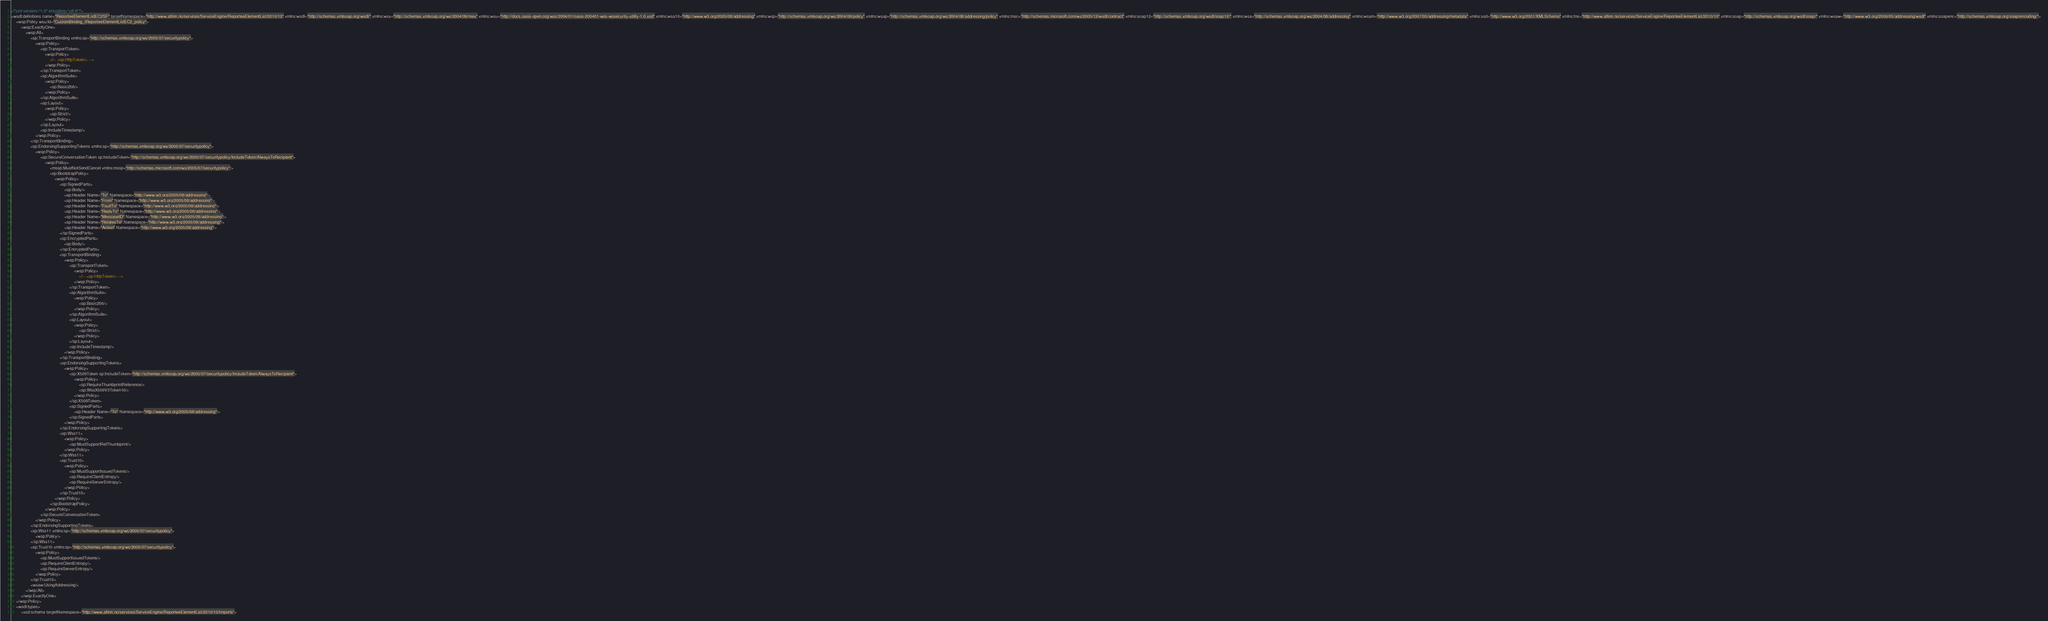<code> <loc_0><loc_0><loc_500><loc_500><_XML_><?xml version="1.0" encoding="utf-8"?>
<wsdl:definitions name="ReporteeElementListEC2SF" targetNamespace="http://www.altinn.no/services/ServiceEngine/ReporteeElementList/2010/10" xmlns:wsdl="http://schemas.xmlsoap.org/wsdl/" xmlns:wsx="http://schemas.xmlsoap.org/ws/2004/09/mex" xmlns:wsu="http://docs.oasis-open.org/wss/2004/01/oasis-200401-wss-wssecurity-utility-1.0.xsd" xmlns:wsa10="http://www.w3.org/2005/08/addressing" xmlns:wsp="http://schemas.xmlsoap.org/ws/2004/09/policy" xmlns:wsap="http://schemas.xmlsoap.org/ws/2004/08/addressing/policy" xmlns:msc="http://schemas.microsoft.com/ws/2005/12/wsdl/contract" xmlns:soap12="http://schemas.xmlsoap.org/wsdl/soap12/" xmlns:wsa="http://schemas.xmlsoap.org/ws/2004/08/addressing" xmlns:wsam="http://www.w3.org/2007/05/addressing/metadata" xmlns:xsd="http://www.w3.org/2001/XMLSchema" xmlns:tns="http://www.altinn.no/services/ServiceEngine/ReporteeElementList/2010/10" xmlns:soap="http://schemas.xmlsoap.org/wsdl/soap/" xmlns:wsaw="http://www.w3.org/2006/05/addressing/wsdl" xmlns:soapenc="http://schemas.xmlsoap.org/soap/encoding/">
    <wsp:Policy wsu:Id="CustomBinding_IReporteeElementListEC2_policy">
        <wsp:ExactlyOne>
            <wsp:All>
                <sp:TransportBinding xmlns:sp="http://schemas.xmlsoap.org/ws/2005/07/securitypolicy">
                    <wsp:Policy>
                        <sp:TransportToken>
                            <wsp:Policy>
                                <!-- <sp:HttpToken/> -->
                            </wsp:Policy>
                        </sp:TransportToken>
                        <sp:AlgorithmSuite>
                            <wsp:Policy>
                                <sp:Basic256/>
                            </wsp:Policy>
                        </sp:AlgorithmSuite>
                        <sp:Layout>
                            <wsp:Policy>
                                <sp:Strict/>
                            </wsp:Policy>
                        </sp:Layout>
                        <sp:IncludeTimestamp/>
                    </wsp:Policy>
                </sp:TransportBinding>
                <sp:EndorsingSupportingTokens xmlns:sp="http://schemas.xmlsoap.org/ws/2005/07/securitypolicy">
                    <wsp:Policy>
                        <sp:SecureConversationToken sp:IncludeToken="http://schemas.xmlsoap.org/ws/2005/07/securitypolicy/IncludeToken/AlwaysToRecipient">
                            <wsp:Policy>
                                <mssp:MustNotSendCancel xmlns:mssp="http://schemas.microsoft.com/ws/2005/07/securitypolicy"/>
                                <sp:BootstrapPolicy>
                                    <wsp:Policy>
                                        <sp:SignedParts>
                                            <sp:Body/>
                                            <sp:Header Name="To" Namespace="http://www.w3.org/2005/08/addressing"/>
                                            <sp:Header Name="From" Namespace="http://www.w3.org/2005/08/addressing"/>
                                            <sp:Header Name="FaultTo" Namespace="http://www.w3.org/2005/08/addressing"/>
                                            <sp:Header Name="ReplyTo" Namespace="http://www.w3.org/2005/08/addressing"/>
                                            <sp:Header Name="MessageID" Namespace="http://www.w3.org/2005/08/addressing"/>
                                            <sp:Header Name="RelatesTo" Namespace="http://www.w3.org/2005/08/addressing"/>
                                            <sp:Header Name="Action" Namespace="http://www.w3.org/2005/08/addressing"/>
                                        </sp:SignedParts>
                                        <sp:EncryptedParts>
                                            <sp:Body/>
                                        </sp:EncryptedParts>
                                        <sp:TransportBinding>
                                            <wsp:Policy>
                                                <sp:TransportToken>
                                                    <wsp:Policy>
                                                        <!-- <sp:HttpToken/> -->
                                                    </wsp:Policy>
                                                </sp:TransportToken>
                                                <sp:AlgorithmSuite>
                                                    <wsp:Policy>
                                                        <sp:Basic256/>
                                                    </wsp:Policy>
                                                </sp:AlgorithmSuite>
                                                <sp:Layout>
                                                    <wsp:Policy>
                                                        <sp:Strict/>
                                                    </wsp:Policy>
                                                </sp:Layout>
                                                <sp:IncludeTimestamp/>
                                            </wsp:Policy>
                                        </sp:TransportBinding>
                                        <sp:EndorsingSupportingTokens>
                                            <wsp:Policy>
                                                <sp:X509Token sp:IncludeToken="http://schemas.xmlsoap.org/ws/2005/07/securitypolicy/IncludeToken/AlwaysToRecipient">
                                                    <wsp:Policy>
                                                        <sp:RequireThumbprintReference/>
                                                        <sp:WssX509V3Token10/>
                                                    </wsp:Policy>
                                                </sp:X509Token>
                                                <sp:SignedParts>
                                                    <sp:Header Name="To" Namespace="http://www.w3.org/2005/08/addressing"/>
                                                </sp:SignedParts>
                                            </wsp:Policy>
                                        </sp:EndorsingSupportingTokens>
                                        <sp:Wss11>
                                            <wsp:Policy>
                                                <sp:MustSupportRefThumbprint/>
                                            </wsp:Policy>
                                        </sp:Wss11>
                                        <sp:Trust10>
                                            <wsp:Policy>
                                                <sp:MustSupportIssuedTokens/>
                                                <sp:RequireClientEntropy/>
                                                <sp:RequireServerEntropy/>
                                            </wsp:Policy>
                                        </sp:Trust10>
                                    </wsp:Policy>
                                </sp:BootstrapPolicy>
                            </wsp:Policy>
                        </sp:SecureConversationToken>
                    </wsp:Policy>
                </sp:EndorsingSupportingTokens>
                <sp:Wss11 xmlns:sp="http://schemas.xmlsoap.org/ws/2005/07/securitypolicy">
                    <wsp:Policy/>
                </sp:Wss11>
                <sp:Trust10 xmlns:sp="http://schemas.xmlsoap.org/ws/2005/07/securitypolicy">
                    <wsp:Policy>
                        <sp:MustSupportIssuedTokens/>
                        <sp:RequireClientEntropy/>
                        <sp:RequireServerEntropy/>
                    </wsp:Policy>
                </sp:Trust10>
                <wsaw:UsingAddressing/>
            </wsp:All>
        </wsp:ExactlyOne>
    </wsp:Policy>
    <wsdl:types>
        <xsd:schema targetNamespace="http://www.altinn.no/services/ServiceEngine/ReporteeElementList/2010/10/Imports"></code> 